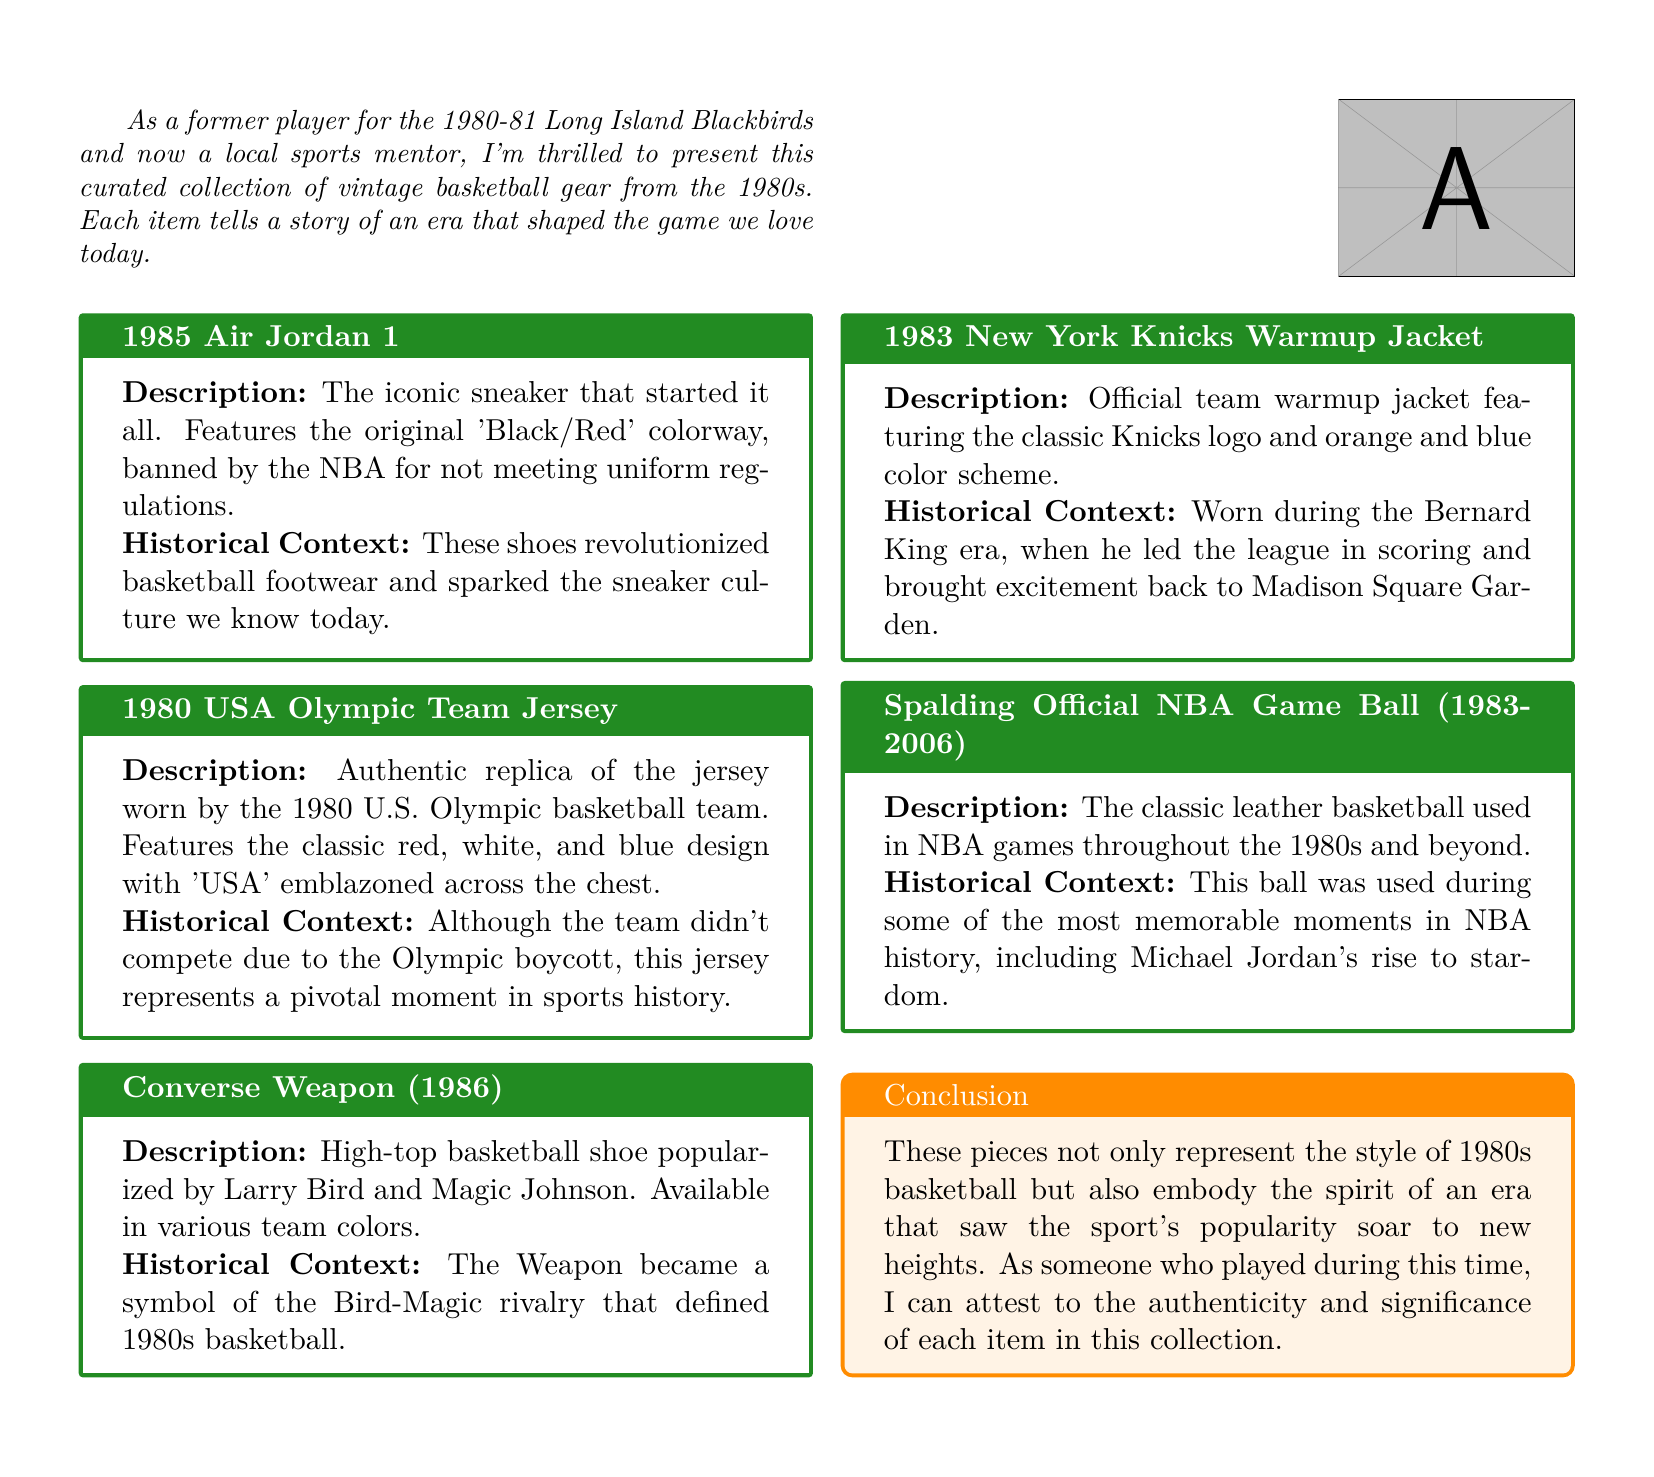what year was the Air Jordan 1 released? The Air Jordan 1 was released in 1985, as stated in the product description.
Answer: 1985 what colorway is associated with the Air Jordan 1? The Air Jordan 1 features the original 'Black/Red' colorway, mentioned in the description.
Answer: Black/Red which Olympic team jersey is featured in the collection? The collection includes the 1980 USA Olympic Team Jersey, as indicated in the document.
Answer: 1980 USA Olympic Team Jersey who popularized the Converse Weapon shoe? The Converse Weapon was popularized by Larry Bird and Magic Johnson, as described in the historical context.
Answer: Larry Bird and Magic Johnson what is the classic color scheme of the New York Knicks warmup jacket? The warmup jacket features the classic orange and blue color scheme, explained in the context.
Answer: Orange and blue what significant event is associated with the 1980 USA Olympic Team Jersey? The jersey represents the Olympic boycott in 1980, as mentioned in the historical context.
Answer: Olympic boycott which basketball was used in NBA games from 1983 to 2006? The Spalding Official NBA Game Ball was used during this period, described in the document.
Answer: Spalding Official NBA Game Ball in which era was the New York Knicks Warmup Jacket worn? The jacket was worn during the Bernard King era, as stated in the historical context.
Answer: Bernard King era what rivalry is the Converse Weapon known for representing? The Converse Weapon symbolizes the Bird-Magic rivalry of the 1980s.
Answer: Bird-Magic rivalry 